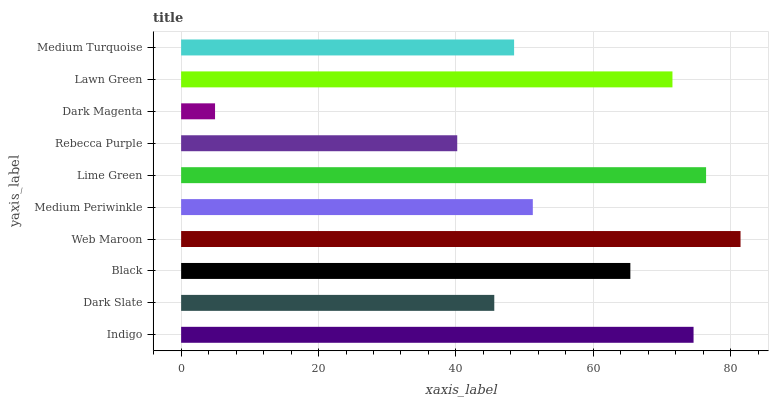Is Dark Magenta the minimum?
Answer yes or no. Yes. Is Web Maroon the maximum?
Answer yes or no. Yes. Is Dark Slate the minimum?
Answer yes or no. No. Is Dark Slate the maximum?
Answer yes or no. No. Is Indigo greater than Dark Slate?
Answer yes or no. Yes. Is Dark Slate less than Indigo?
Answer yes or no. Yes. Is Dark Slate greater than Indigo?
Answer yes or no. No. Is Indigo less than Dark Slate?
Answer yes or no. No. Is Black the high median?
Answer yes or no. Yes. Is Medium Periwinkle the low median?
Answer yes or no. Yes. Is Dark Magenta the high median?
Answer yes or no. No. Is Lawn Green the low median?
Answer yes or no. No. 